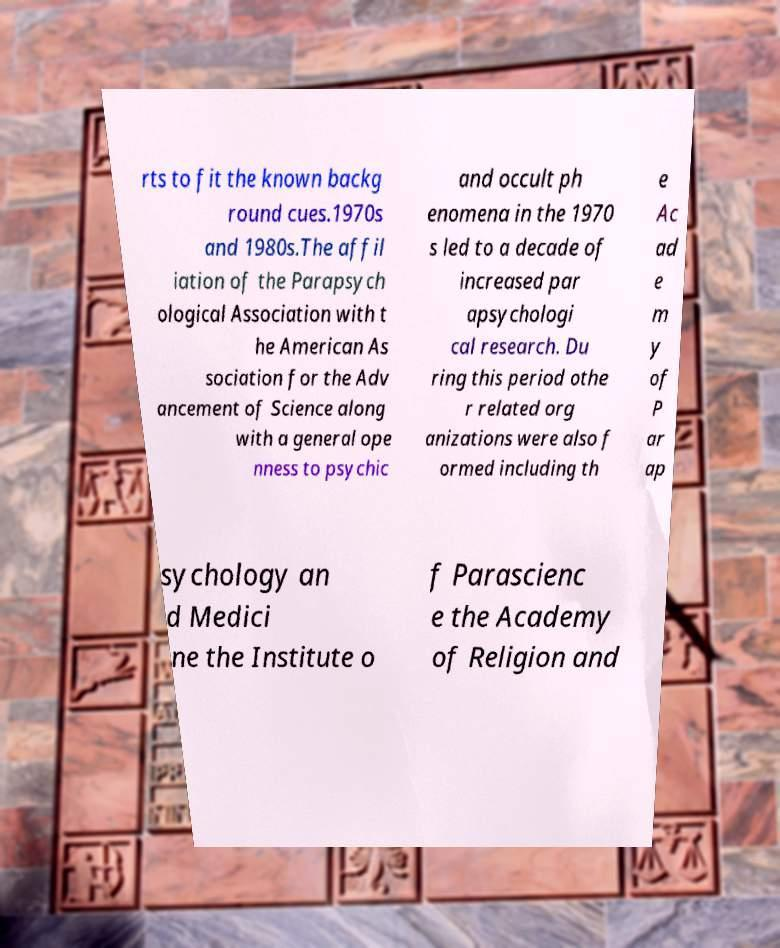For documentation purposes, I need the text within this image transcribed. Could you provide that? rts to fit the known backg round cues.1970s and 1980s.The affil iation of the Parapsych ological Association with t he American As sociation for the Adv ancement of Science along with a general ope nness to psychic and occult ph enomena in the 1970 s led to a decade of increased par apsychologi cal research. Du ring this period othe r related org anizations were also f ormed including th e Ac ad e m y of P ar ap sychology an d Medici ne the Institute o f Parascienc e the Academy of Religion and 